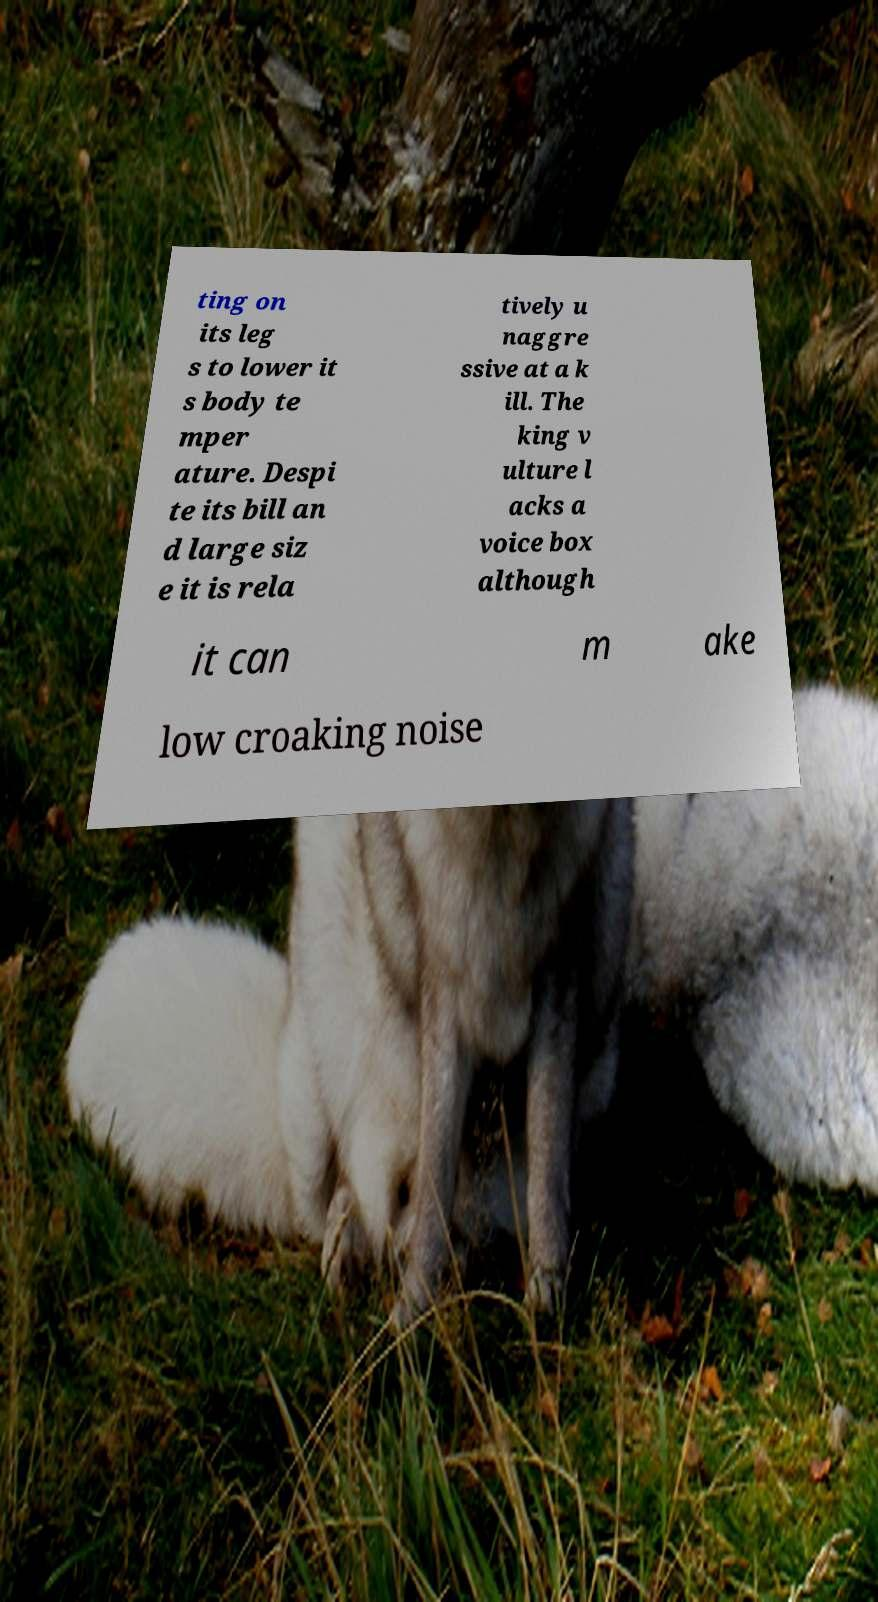Please identify and transcribe the text found in this image. ting on its leg s to lower it s body te mper ature. Despi te its bill an d large siz e it is rela tively u naggre ssive at a k ill. The king v ulture l acks a voice box although it can m ake low croaking noise 